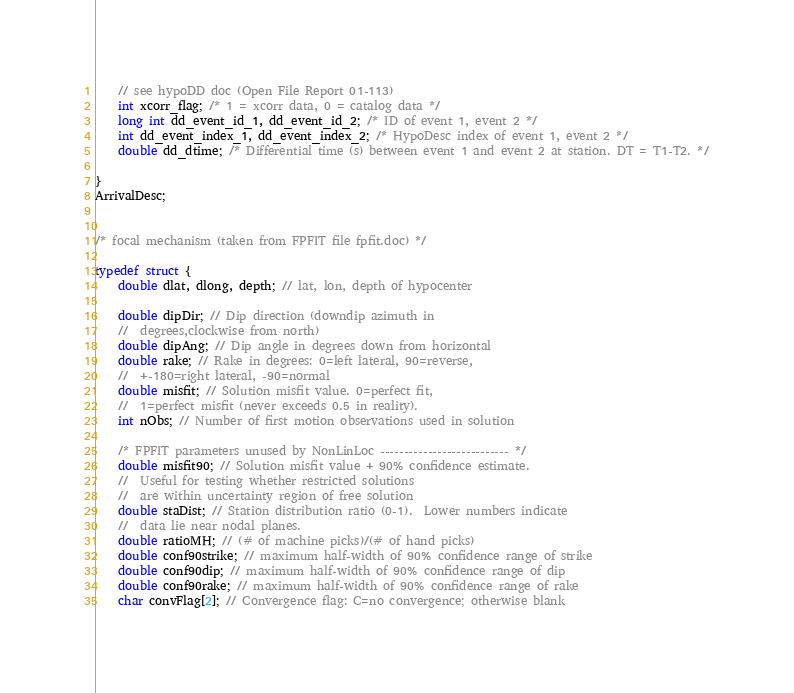Convert code to text. <code><loc_0><loc_0><loc_500><loc_500><_C_>    // see hypoDD doc (Open File Report 01-113)
    int xcorr_flag; /* 1 = xcorr data, 0 = catalog data */
    long int dd_event_id_1, dd_event_id_2; /* ID of event 1, event 2 */
    int dd_event_index_1, dd_event_index_2; /* HypoDesc index of event 1, event 2 */
    double dd_dtime; /* Differential time (s) between event 1 and event 2 at station. DT = T1-T2. */

}
ArrivalDesc;


/* focal mechanism (taken from FPFIT file fpfit.doc) */

typedef struct {
    double dlat, dlong, depth; // lat, lon, depth of hypocenter

    double dipDir; // Dip direction (downdip azimuth in
    //	degrees,clockwise from north)
    double dipAng; // Dip angle in degrees down from horizontal
    double rake; // Rake in degrees: 0=left lateral, 90=reverse,
    //	+-180=right lateral, -90=normal
    double misfit; // Solution misfit value. 0=perfect fit,
    //	1=perfect misfit (never exceeds 0.5 in reality).
    int nObs; // Number of first motion observations used in solution

    /* FPFIT parameters unused by NonLinLoc --------------------------- */
    double misfit90; // Solution misfit value + 90% confidence estimate.
    //	Useful for testing whether restricted solutions
    //	are within uncertainty region of free solution
    double staDist; // Station distribution ratio (0-1).  Lower numbers indicate
    //	data lie near nodal planes.
    double ratioMH; // (# of machine picks)/(# of hand picks)
    double conf90strike; // maximum half-width of 90% confidence range of strike
    double conf90dip; // maximum half-width of 90% confidence range of dip
    double conf90rake; // maximum half-width of 90% confidence range of rake
    char convFlag[2]; // Convergence flag: C=no convergence; otherwise blank</code> 